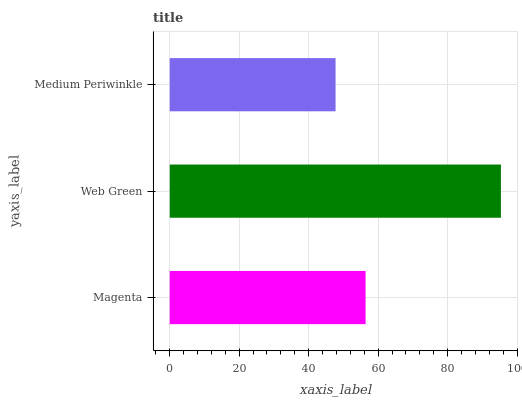Is Medium Periwinkle the minimum?
Answer yes or no. Yes. Is Web Green the maximum?
Answer yes or no. Yes. Is Web Green the minimum?
Answer yes or no. No. Is Medium Periwinkle the maximum?
Answer yes or no. No. Is Web Green greater than Medium Periwinkle?
Answer yes or no. Yes. Is Medium Periwinkle less than Web Green?
Answer yes or no. Yes. Is Medium Periwinkle greater than Web Green?
Answer yes or no. No. Is Web Green less than Medium Periwinkle?
Answer yes or no. No. Is Magenta the high median?
Answer yes or no. Yes. Is Magenta the low median?
Answer yes or no. Yes. Is Web Green the high median?
Answer yes or no. No. Is Web Green the low median?
Answer yes or no. No. 